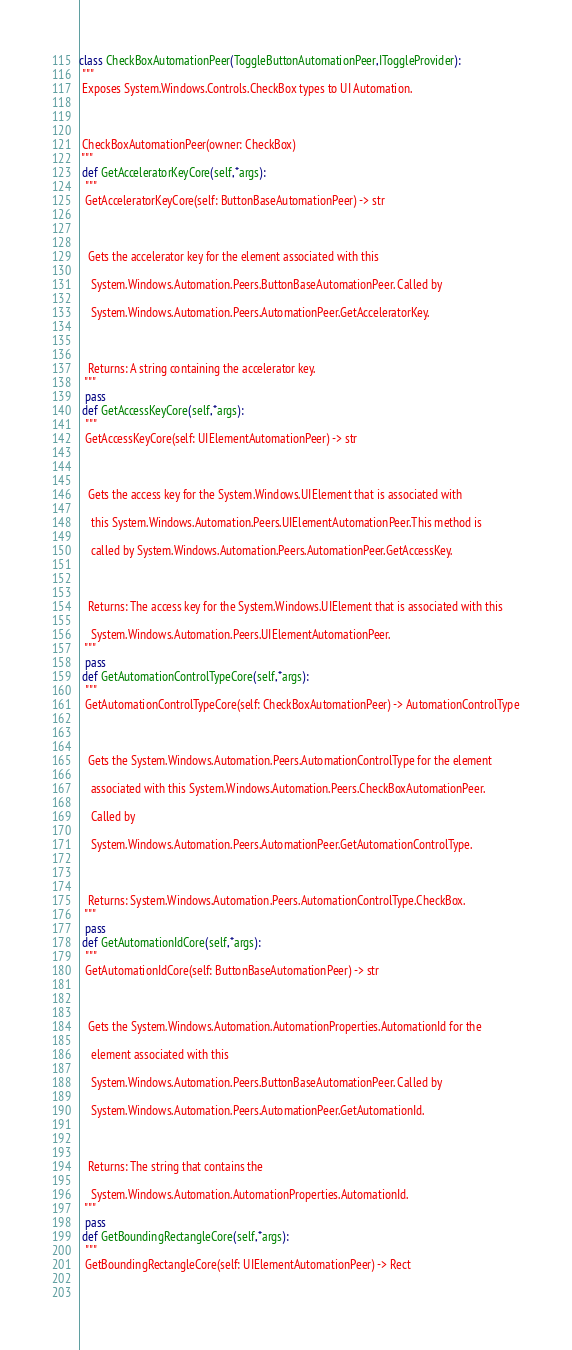<code> <loc_0><loc_0><loc_500><loc_500><_Python_>class CheckBoxAutomationPeer(ToggleButtonAutomationPeer,IToggleProvider):
 """
 Exposes System.Windows.Controls.CheckBox types to UI Automation.
 
 CheckBoxAutomationPeer(owner: CheckBox)
 """
 def GetAcceleratorKeyCore(self,*args):
  """
  GetAcceleratorKeyCore(self: ButtonBaseAutomationPeer) -> str
  
   Gets the accelerator key for the element associated with this 
    System.Windows.Automation.Peers.ButtonBaseAutomationPeer. Called by 
    System.Windows.Automation.Peers.AutomationPeer.GetAcceleratorKey.
  
   Returns: A string containing the accelerator key.
  """
  pass
 def GetAccessKeyCore(self,*args):
  """
  GetAccessKeyCore(self: UIElementAutomationPeer) -> str
  
   Gets the access key for the System.Windows.UIElement that is associated with 
    this System.Windows.Automation.Peers.UIElementAutomationPeer.This method is 
    called by System.Windows.Automation.Peers.AutomationPeer.GetAccessKey.
  
   Returns: The access key for the System.Windows.UIElement that is associated with this 
    System.Windows.Automation.Peers.UIElementAutomationPeer.
  """
  pass
 def GetAutomationControlTypeCore(self,*args):
  """
  GetAutomationControlTypeCore(self: CheckBoxAutomationPeer) -> AutomationControlType
  
   Gets the System.Windows.Automation.Peers.AutomationControlType for the element 
    associated with this System.Windows.Automation.Peers.CheckBoxAutomationPeer. 
    Called by 
    System.Windows.Automation.Peers.AutomationPeer.GetAutomationControlType.
  
   Returns: System.Windows.Automation.Peers.AutomationControlType.CheckBox.
  """
  pass
 def GetAutomationIdCore(self,*args):
  """
  GetAutomationIdCore(self: ButtonBaseAutomationPeer) -> str
  
   Gets the System.Windows.Automation.AutomationProperties.AutomationId for the 
    element associated with this 
    System.Windows.Automation.Peers.ButtonBaseAutomationPeer. Called by 
    System.Windows.Automation.Peers.AutomationPeer.GetAutomationId.
  
   Returns: The string that contains the 
    System.Windows.Automation.AutomationProperties.AutomationId.
  """
  pass
 def GetBoundingRectangleCore(self,*args):
  """
  GetBoundingRectangleCore(self: UIElementAutomationPeer) -> Rect
  </code> 